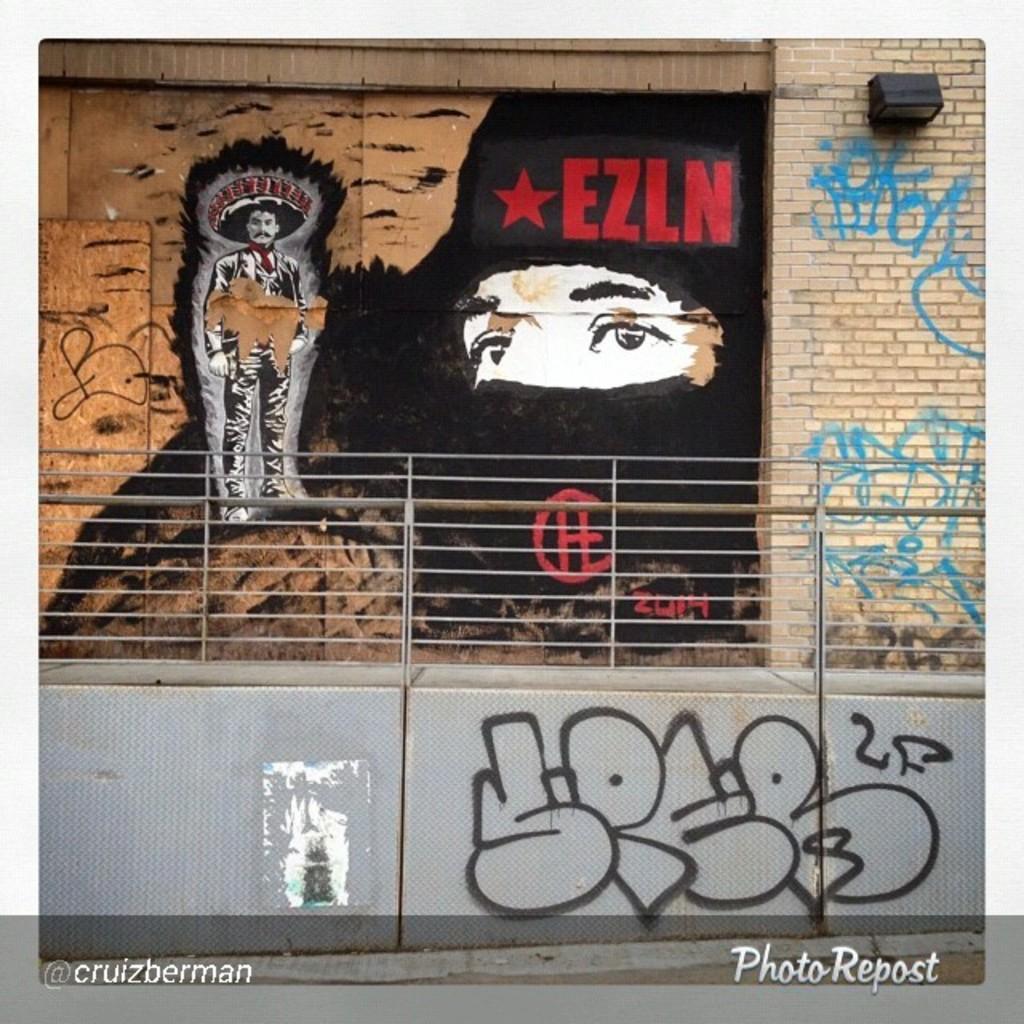Please provide a concise description of this image. In this picture I can see there is painting on the wall, it is the painting of a man, standing and wearing a cap and there is a person´s picture and there is something written on the wall and on to right there is a black color object attached to the wall and there is a iron bridge here. 